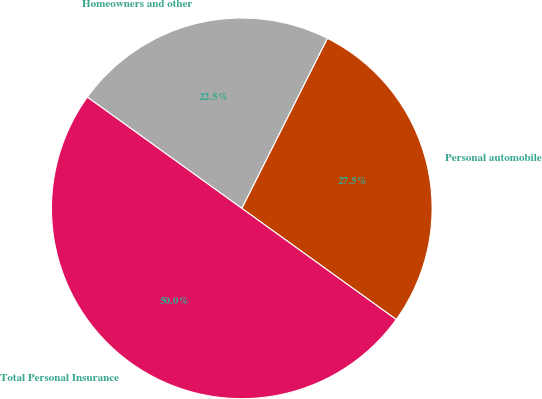Convert chart to OTSL. <chart><loc_0><loc_0><loc_500><loc_500><pie_chart><fcel>Personal automobile<fcel>Homeowners and other<fcel>Total Personal Insurance<nl><fcel>27.51%<fcel>22.49%<fcel>50.0%<nl></chart> 